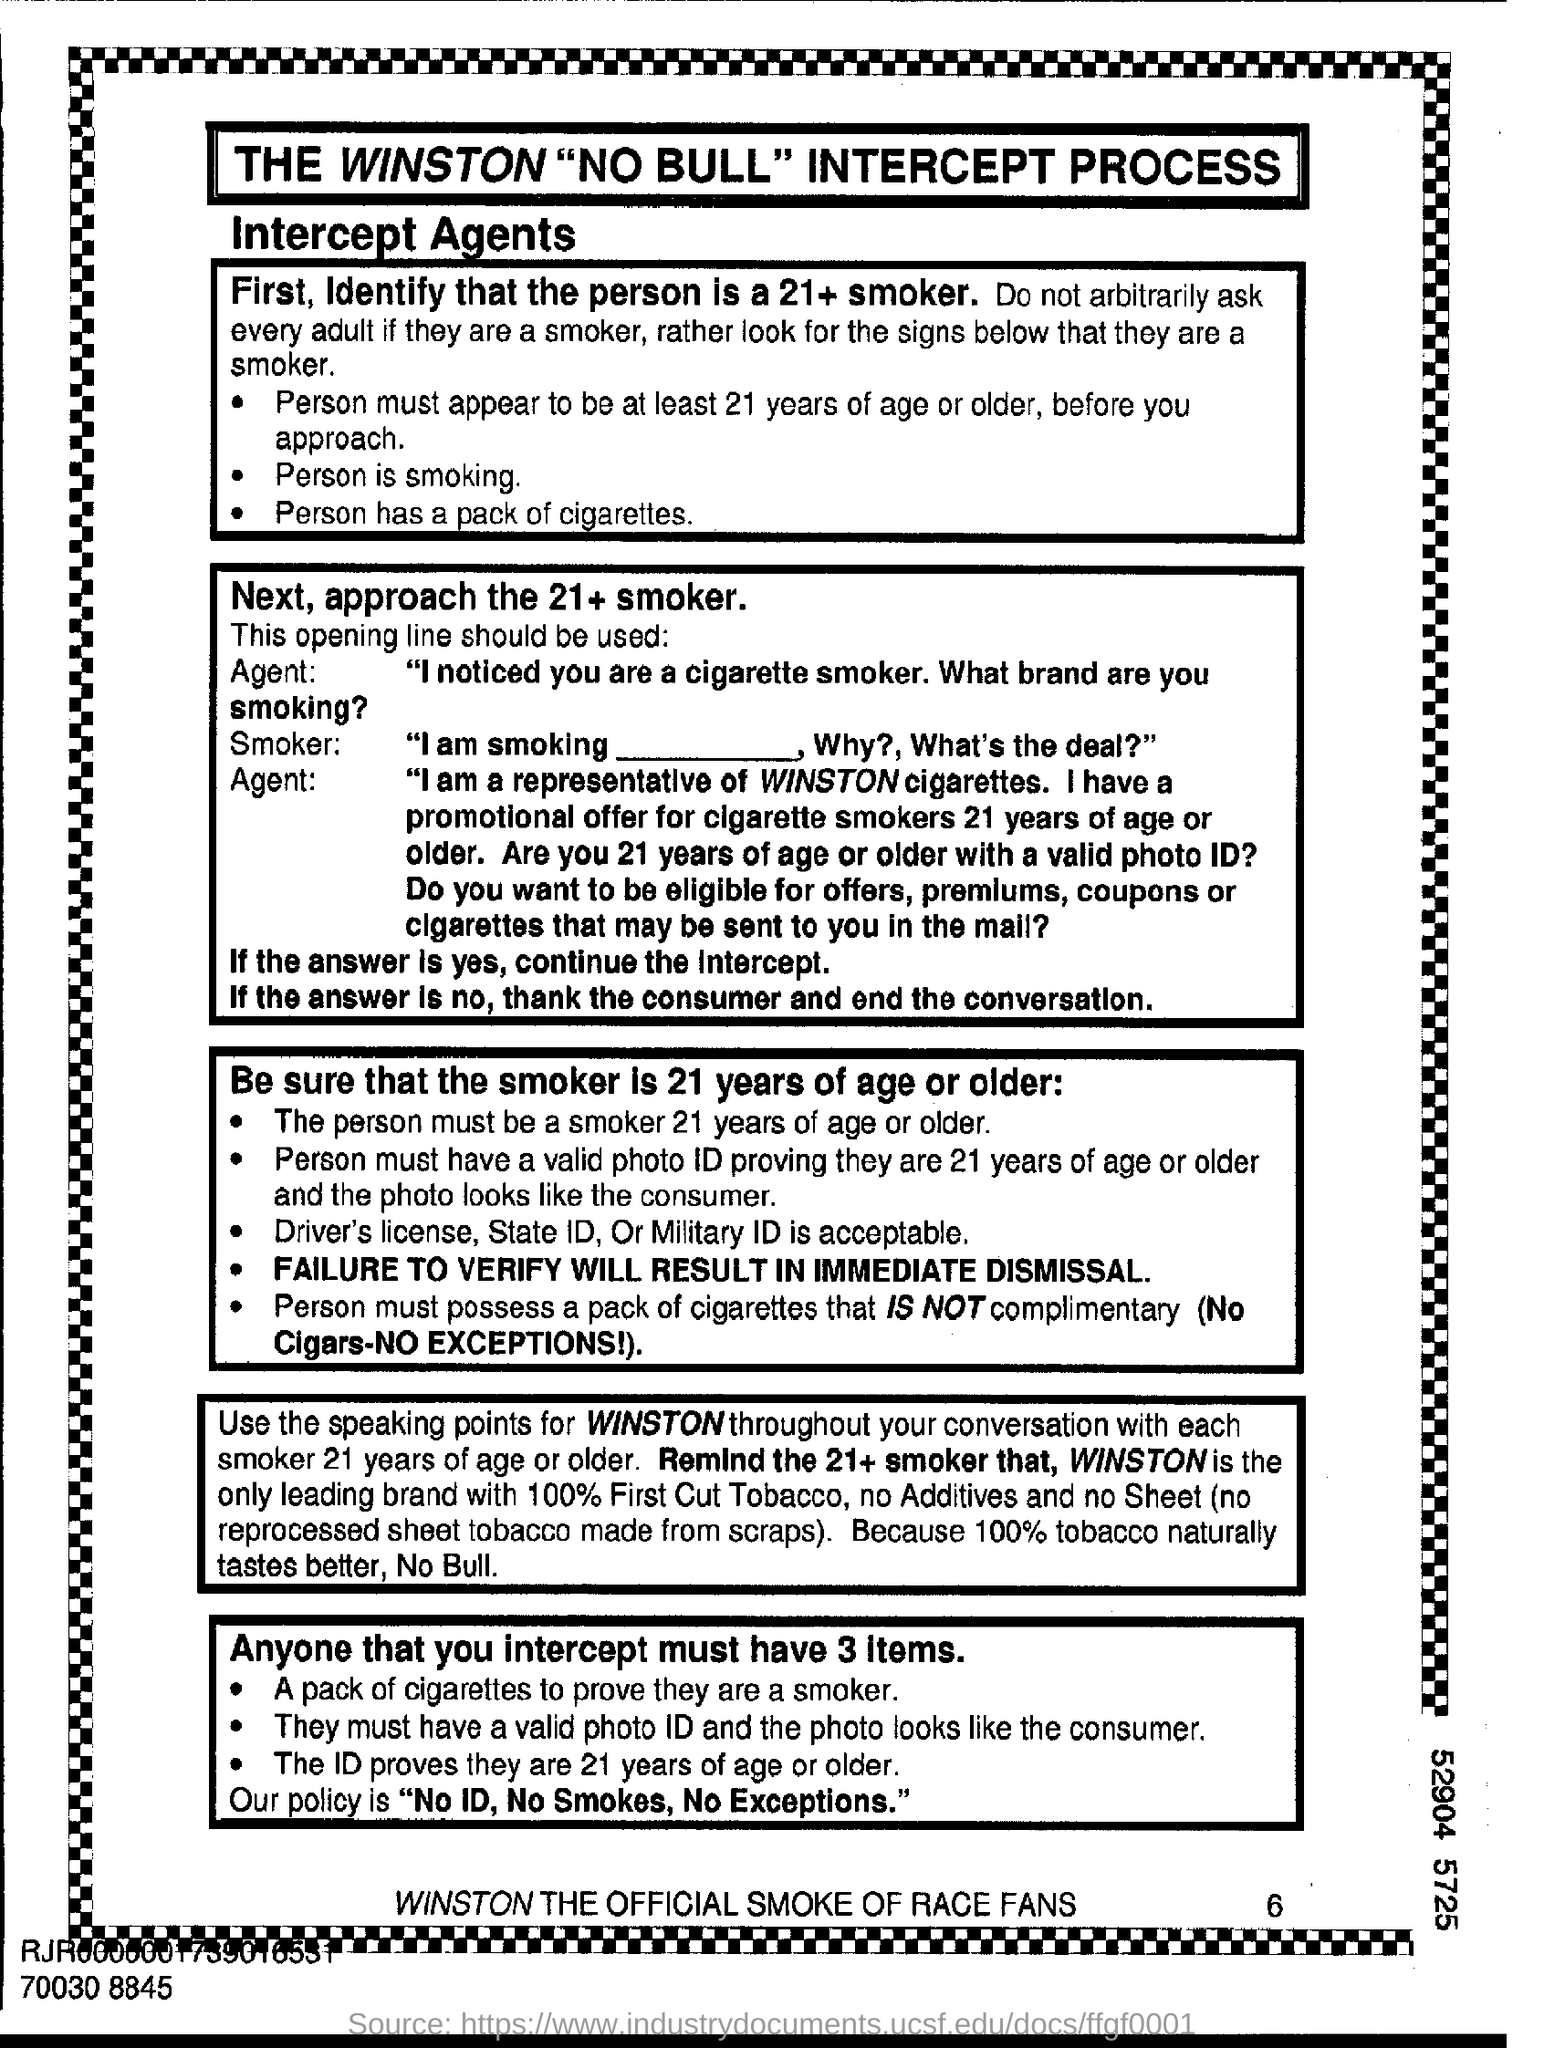Draw attention to some important aspects in this diagram. It is acceptable for individuals who are 21 years or older to use their driver's license, state ID, or military ID as identification if they are a smoker. 